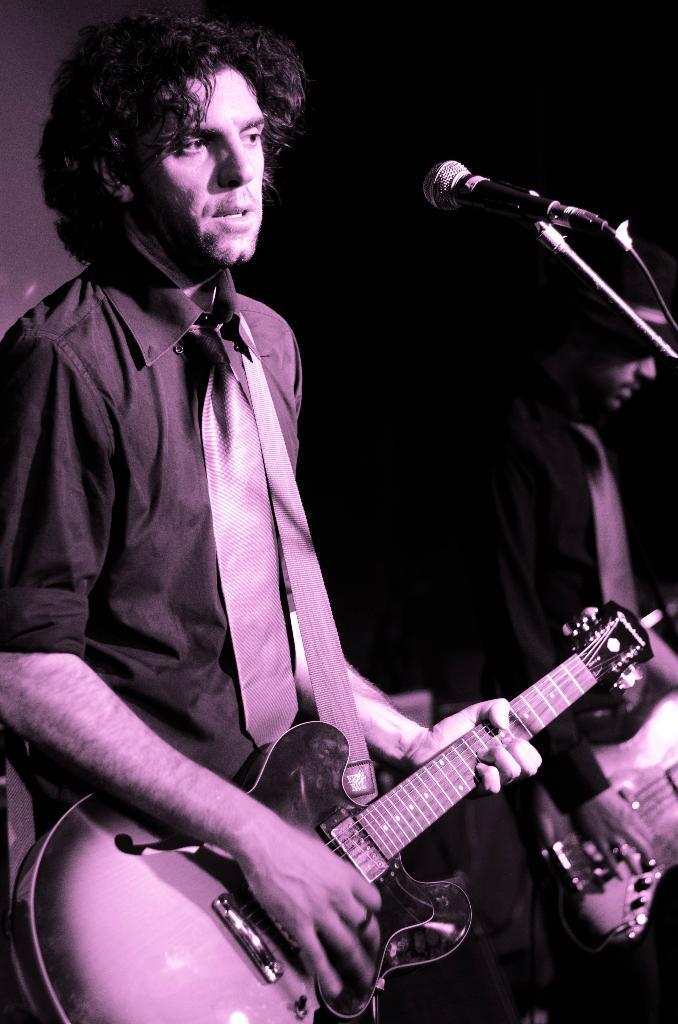Please provide a concise description of this image. The two persons are standing on a stage. They are both playing a musical instruments. 